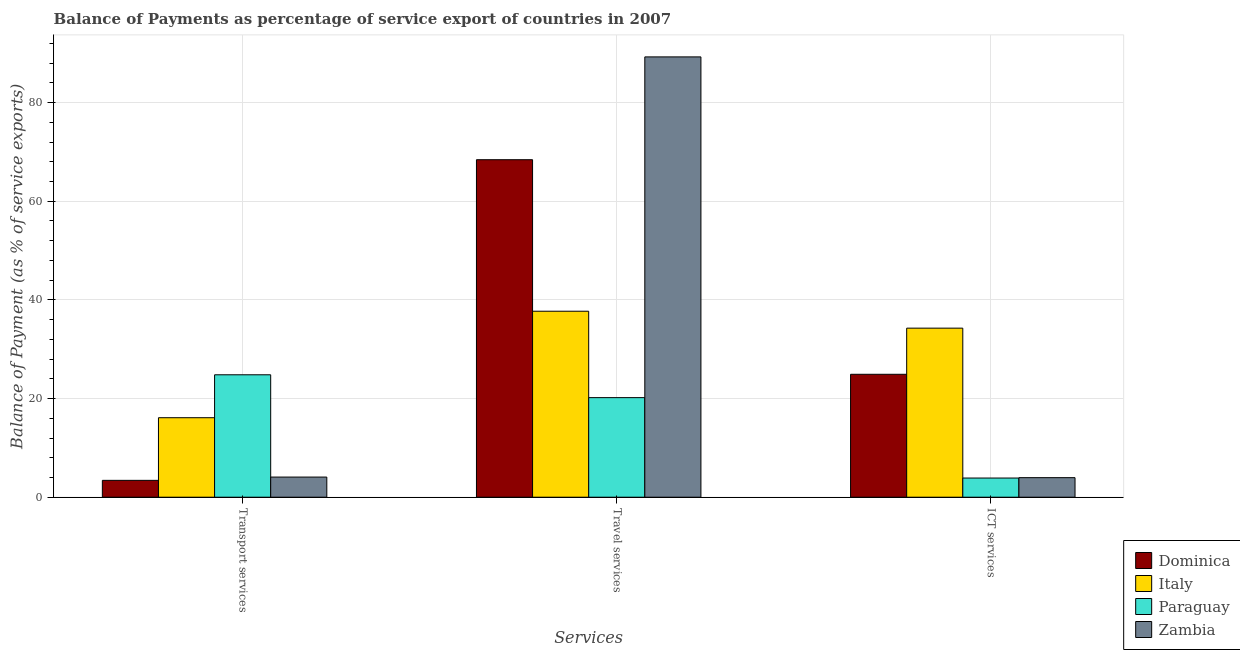How many different coloured bars are there?
Provide a short and direct response. 4. How many groups of bars are there?
Your answer should be compact. 3. Are the number of bars per tick equal to the number of legend labels?
Offer a very short reply. Yes. Are the number of bars on each tick of the X-axis equal?
Provide a short and direct response. Yes. How many bars are there on the 1st tick from the right?
Offer a terse response. 4. What is the label of the 1st group of bars from the left?
Your response must be concise. Transport services. What is the balance of payment of transport services in Zambia?
Provide a short and direct response. 4.08. Across all countries, what is the maximum balance of payment of ict services?
Your answer should be very brief. 34.28. Across all countries, what is the minimum balance of payment of ict services?
Ensure brevity in your answer.  3.89. In which country was the balance of payment of travel services maximum?
Make the answer very short. Zambia. In which country was the balance of payment of transport services minimum?
Provide a short and direct response. Dominica. What is the total balance of payment of transport services in the graph?
Offer a terse response. 48.45. What is the difference between the balance of payment of ict services in Italy and that in Dominica?
Give a very brief answer. 9.35. What is the difference between the balance of payment of ict services in Dominica and the balance of payment of transport services in Zambia?
Your response must be concise. 20.84. What is the average balance of payment of travel services per country?
Your answer should be very brief. 53.9. What is the difference between the balance of payment of travel services and balance of payment of ict services in Paraguay?
Offer a very short reply. 16.3. In how many countries, is the balance of payment of travel services greater than 56 %?
Give a very brief answer. 2. What is the ratio of the balance of payment of ict services in Dominica to that in Paraguay?
Your response must be concise. 6.41. Is the difference between the balance of payment of ict services in Paraguay and Zambia greater than the difference between the balance of payment of travel services in Paraguay and Zambia?
Give a very brief answer. Yes. What is the difference between the highest and the second highest balance of payment of travel services?
Keep it short and to the point. 20.84. What is the difference between the highest and the lowest balance of payment of ict services?
Your response must be concise. 30.39. Is the sum of the balance of payment of transport services in Dominica and Paraguay greater than the maximum balance of payment of travel services across all countries?
Provide a short and direct response. No. Is it the case that in every country, the sum of the balance of payment of transport services and balance of payment of travel services is greater than the balance of payment of ict services?
Provide a succinct answer. Yes. Are the values on the major ticks of Y-axis written in scientific E-notation?
Ensure brevity in your answer.  No. Does the graph contain any zero values?
Provide a short and direct response. No. How many legend labels are there?
Give a very brief answer. 4. What is the title of the graph?
Provide a succinct answer. Balance of Payments as percentage of service export of countries in 2007. Does "High income: OECD" appear as one of the legend labels in the graph?
Your response must be concise. No. What is the label or title of the X-axis?
Your response must be concise. Services. What is the label or title of the Y-axis?
Your response must be concise. Balance of Payment (as % of service exports). What is the Balance of Payment (as % of service exports) of Dominica in Transport services?
Offer a very short reply. 3.42. What is the Balance of Payment (as % of service exports) in Italy in Transport services?
Provide a short and direct response. 16.12. What is the Balance of Payment (as % of service exports) in Paraguay in Transport services?
Make the answer very short. 24.82. What is the Balance of Payment (as % of service exports) in Zambia in Transport services?
Provide a short and direct response. 4.08. What is the Balance of Payment (as % of service exports) of Dominica in Travel services?
Your answer should be very brief. 68.43. What is the Balance of Payment (as % of service exports) in Italy in Travel services?
Provide a short and direct response. 37.71. What is the Balance of Payment (as % of service exports) of Paraguay in Travel services?
Keep it short and to the point. 20.19. What is the Balance of Payment (as % of service exports) in Zambia in Travel services?
Give a very brief answer. 89.27. What is the Balance of Payment (as % of service exports) of Dominica in ICT services?
Ensure brevity in your answer.  24.92. What is the Balance of Payment (as % of service exports) of Italy in ICT services?
Give a very brief answer. 34.28. What is the Balance of Payment (as % of service exports) in Paraguay in ICT services?
Your response must be concise. 3.89. What is the Balance of Payment (as % of service exports) in Zambia in ICT services?
Provide a succinct answer. 3.96. Across all Services, what is the maximum Balance of Payment (as % of service exports) in Dominica?
Your answer should be compact. 68.43. Across all Services, what is the maximum Balance of Payment (as % of service exports) in Italy?
Your answer should be compact. 37.71. Across all Services, what is the maximum Balance of Payment (as % of service exports) in Paraguay?
Offer a terse response. 24.82. Across all Services, what is the maximum Balance of Payment (as % of service exports) in Zambia?
Provide a succinct answer. 89.27. Across all Services, what is the minimum Balance of Payment (as % of service exports) in Dominica?
Your answer should be very brief. 3.42. Across all Services, what is the minimum Balance of Payment (as % of service exports) of Italy?
Ensure brevity in your answer.  16.12. Across all Services, what is the minimum Balance of Payment (as % of service exports) in Paraguay?
Your response must be concise. 3.89. Across all Services, what is the minimum Balance of Payment (as % of service exports) in Zambia?
Make the answer very short. 3.96. What is the total Balance of Payment (as % of service exports) of Dominica in the graph?
Keep it short and to the point. 96.77. What is the total Balance of Payment (as % of service exports) of Italy in the graph?
Make the answer very short. 88.1. What is the total Balance of Payment (as % of service exports) of Paraguay in the graph?
Offer a terse response. 48.9. What is the total Balance of Payment (as % of service exports) of Zambia in the graph?
Offer a very short reply. 97.32. What is the difference between the Balance of Payment (as % of service exports) in Dominica in Transport services and that in Travel services?
Your answer should be compact. -65.01. What is the difference between the Balance of Payment (as % of service exports) in Italy in Transport services and that in Travel services?
Make the answer very short. -21.59. What is the difference between the Balance of Payment (as % of service exports) of Paraguay in Transport services and that in Travel services?
Keep it short and to the point. 4.63. What is the difference between the Balance of Payment (as % of service exports) of Zambia in Transport services and that in Travel services?
Provide a short and direct response. -85.19. What is the difference between the Balance of Payment (as % of service exports) in Dominica in Transport services and that in ICT services?
Your response must be concise. -21.5. What is the difference between the Balance of Payment (as % of service exports) in Italy in Transport services and that in ICT services?
Your answer should be very brief. -18.16. What is the difference between the Balance of Payment (as % of service exports) of Paraguay in Transport services and that in ICT services?
Your answer should be very brief. 20.93. What is the difference between the Balance of Payment (as % of service exports) of Zambia in Transport services and that in ICT services?
Your answer should be very brief. 0.12. What is the difference between the Balance of Payment (as % of service exports) of Dominica in Travel services and that in ICT services?
Keep it short and to the point. 43.5. What is the difference between the Balance of Payment (as % of service exports) in Italy in Travel services and that in ICT services?
Your response must be concise. 3.43. What is the difference between the Balance of Payment (as % of service exports) of Paraguay in Travel services and that in ICT services?
Offer a very short reply. 16.3. What is the difference between the Balance of Payment (as % of service exports) in Zambia in Travel services and that in ICT services?
Provide a short and direct response. 85.31. What is the difference between the Balance of Payment (as % of service exports) in Dominica in Transport services and the Balance of Payment (as % of service exports) in Italy in Travel services?
Provide a succinct answer. -34.29. What is the difference between the Balance of Payment (as % of service exports) of Dominica in Transport services and the Balance of Payment (as % of service exports) of Paraguay in Travel services?
Ensure brevity in your answer.  -16.77. What is the difference between the Balance of Payment (as % of service exports) of Dominica in Transport services and the Balance of Payment (as % of service exports) of Zambia in Travel services?
Offer a terse response. -85.85. What is the difference between the Balance of Payment (as % of service exports) of Italy in Transport services and the Balance of Payment (as % of service exports) of Paraguay in Travel services?
Ensure brevity in your answer.  -4.07. What is the difference between the Balance of Payment (as % of service exports) of Italy in Transport services and the Balance of Payment (as % of service exports) of Zambia in Travel services?
Make the answer very short. -73.15. What is the difference between the Balance of Payment (as % of service exports) in Paraguay in Transport services and the Balance of Payment (as % of service exports) in Zambia in Travel services?
Your answer should be compact. -64.45. What is the difference between the Balance of Payment (as % of service exports) of Dominica in Transport services and the Balance of Payment (as % of service exports) of Italy in ICT services?
Offer a terse response. -30.85. What is the difference between the Balance of Payment (as % of service exports) in Dominica in Transport services and the Balance of Payment (as % of service exports) in Paraguay in ICT services?
Give a very brief answer. -0.47. What is the difference between the Balance of Payment (as % of service exports) of Dominica in Transport services and the Balance of Payment (as % of service exports) of Zambia in ICT services?
Make the answer very short. -0.54. What is the difference between the Balance of Payment (as % of service exports) in Italy in Transport services and the Balance of Payment (as % of service exports) in Paraguay in ICT services?
Your answer should be very brief. 12.23. What is the difference between the Balance of Payment (as % of service exports) of Italy in Transport services and the Balance of Payment (as % of service exports) of Zambia in ICT services?
Offer a terse response. 12.15. What is the difference between the Balance of Payment (as % of service exports) of Paraguay in Transport services and the Balance of Payment (as % of service exports) of Zambia in ICT services?
Your answer should be very brief. 20.86. What is the difference between the Balance of Payment (as % of service exports) of Dominica in Travel services and the Balance of Payment (as % of service exports) of Italy in ICT services?
Provide a succinct answer. 34.15. What is the difference between the Balance of Payment (as % of service exports) of Dominica in Travel services and the Balance of Payment (as % of service exports) of Paraguay in ICT services?
Keep it short and to the point. 64.54. What is the difference between the Balance of Payment (as % of service exports) of Dominica in Travel services and the Balance of Payment (as % of service exports) of Zambia in ICT services?
Your response must be concise. 64.46. What is the difference between the Balance of Payment (as % of service exports) in Italy in Travel services and the Balance of Payment (as % of service exports) in Paraguay in ICT services?
Offer a terse response. 33.82. What is the difference between the Balance of Payment (as % of service exports) in Italy in Travel services and the Balance of Payment (as % of service exports) in Zambia in ICT services?
Offer a very short reply. 33.74. What is the difference between the Balance of Payment (as % of service exports) in Paraguay in Travel services and the Balance of Payment (as % of service exports) in Zambia in ICT services?
Give a very brief answer. 16.23. What is the average Balance of Payment (as % of service exports) of Dominica per Services?
Your response must be concise. 32.26. What is the average Balance of Payment (as % of service exports) of Italy per Services?
Give a very brief answer. 29.37. What is the average Balance of Payment (as % of service exports) in Paraguay per Services?
Provide a short and direct response. 16.3. What is the average Balance of Payment (as % of service exports) of Zambia per Services?
Your answer should be compact. 32.44. What is the difference between the Balance of Payment (as % of service exports) of Dominica and Balance of Payment (as % of service exports) of Italy in Transport services?
Your answer should be compact. -12.7. What is the difference between the Balance of Payment (as % of service exports) in Dominica and Balance of Payment (as % of service exports) in Paraguay in Transport services?
Offer a very short reply. -21.4. What is the difference between the Balance of Payment (as % of service exports) in Dominica and Balance of Payment (as % of service exports) in Zambia in Transport services?
Offer a very short reply. -0.66. What is the difference between the Balance of Payment (as % of service exports) in Italy and Balance of Payment (as % of service exports) in Paraguay in Transport services?
Offer a very short reply. -8.7. What is the difference between the Balance of Payment (as % of service exports) in Italy and Balance of Payment (as % of service exports) in Zambia in Transport services?
Provide a succinct answer. 12.03. What is the difference between the Balance of Payment (as % of service exports) of Paraguay and Balance of Payment (as % of service exports) of Zambia in Transport services?
Offer a very short reply. 20.74. What is the difference between the Balance of Payment (as % of service exports) of Dominica and Balance of Payment (as % of service exports) of Italy in Travel services?
Give a very brief answer. 30.72. What is the difference between the Balance of Payment (as % of service exports) in Dominica and Balance of Payment (as % of service exports) in Paraguay in Travel services?
Your answer should be very brief. 48.24. What is the difference between the Balance of Payment (as % of service exports) of Dominica and Balance of Payment (as % of service exports) of Zambia in Travel services?
Your answer should be very brief. -20.84. What is the difference between the Balance of Payment (as % of service exports) in Italy and Balance of Payment (as % of service exports) in Paraguay in Travel services?
Provide a short and direct response. 17.52. What is the difference between the Balance of Payment (as % of service exports) of Italy and Balance of Payment (as % of service exports) of Zambia in Travel services?
Ensure brevity in your answer.  -51.56. What is the difference between the Balance of Payment (as % of service exports) of Paraguay and Balance of Payment (as % of service exports) of Zambia in Travel services?
Give a very brief answer. -69.08. What is the difference between the Balance of Payment (as % of service exports) of Dominica and Balance of Payment (as % of service exports) of Italy in ICT services?
Offer a very short reply. -9.35. What is the difference between the Balance of Payment (as % of service exports) of Dominica and Balance of Payment (as % of service exports) of Paraguay in ICT services?
Keep it short and to the point. 21.03. What is the difference between the Balance of Payment (as % of service exports) in Dominica and Balance of Payment (as % of service exports) in Zambia in ICT services?
Offer a terse response. 20.96. What is the difference between the Balance of Payment (as % of service exports) in Italy and Balance of Payment (as % of service exports) in Paraguay in ICT services?
Your answer should be very brief. 30.39. What is the difference between the Balance of Payment (as % of service exports) of Italy and Balance of Payment (as % of service exports) of Zambia in ICT services?
Make the answer very short. 30.31. What is the difference between the Balance of Payment (as % of service exports) of Paraguay and Balance of Payment (as % of service exports) of Zambia in ICT services?
Provide a succinct answer. -0.08. What is the ratio of the Balance of Payment (as % of service exports) of Dominica in Transport services to that in Travel services?
Your answer should be compact. 0.05. What is the ratio of the Balance of Payment (as % of service exports) in Italy in Transport services to that in Travel services?
Provide a succinct answer. 0.43. What is the ratio of the Balance of Payment (as % of service exports) in Paraguay in Transport services to that in Travel services?
Your response must be concise. 1.23. What is the ratio of the Balance of Payment (as % of service exports) of Zambia in Transport services to that in Travel services?
Make the answer very short. 0.05. What is the ratio of the Balance of Payment (as % of service exports) of Dominica in Transport services to that in ICT services?
Your answer should be very brief. 0.14. What is the ratio of the Balance of Payment (as % of service exports) of Italy in Transport services to that in ICT services?
Provide a short and direct response. 0.47. What is the ratio of the Balance of Payment (as % of service exports) of Paraguay in Transport services to that in ICT services?
Offer a very short reply. 6.39. What is the ratio of the Balance of Payment (as % of service exports) of Zambia in Transport services to that in ICT services?
Make the answer very short. 1.03. What is the ratio of the Balance of Payment (as % of service exports) in Dominica in Travel services to that in ICT services?
Your answer should be compact. 2.75. What is the ratio of the Balance of Payment (as % of service exports) of Italy in Travel services to that in ICT services?
Your answer should be very brief. 1.1. What is the ratio of the Balance of Payment (as % of service exports) in Paraguay in Travel services to that in ICT services?
Provide a short and direct response. 5.19. What is the ratio of the Balance of Payment (as % of service exports) in Zambia in Travel services to that in ICT services?
Make the answer very short. 22.52. What is the difference between the highest and the second highest Balance of Payment (as % of service exports) in Dominica?
Offer a terse response. 43.5. What is the difference between the highest and the second highest Balance of Payment (as % of service exports) of Italy?
Make the answer very short. 3.43. What is the difference between the highest and the second highest Balance of Payment (as % of service exports) of Paraguay?
Your answer should be compact. 4.63. What is the difference between the highest and the second highest Balance of Payment (as % of service exports) of Zambia?
Keep it short and to the point. 85.19. What is the difference between the highest and the lowest Balance of Payment (as % of service exports) in Dominica?
Provide a short and direct response. 65.01. What is the difference between the highest and the lowest Balance of Payment (as % of service exports) of Italy?
Your answer should be very brief. 21.59. What is the difference between the highest and the lowest Balance of Payment (as % of service exports) of Paraguay?
Keep it short and to the point. 20.93. What is the difference between the highest and the lowest Balance of Payment (as % of service exports) in Zambia?
Offer a very short reply. 85.31. 